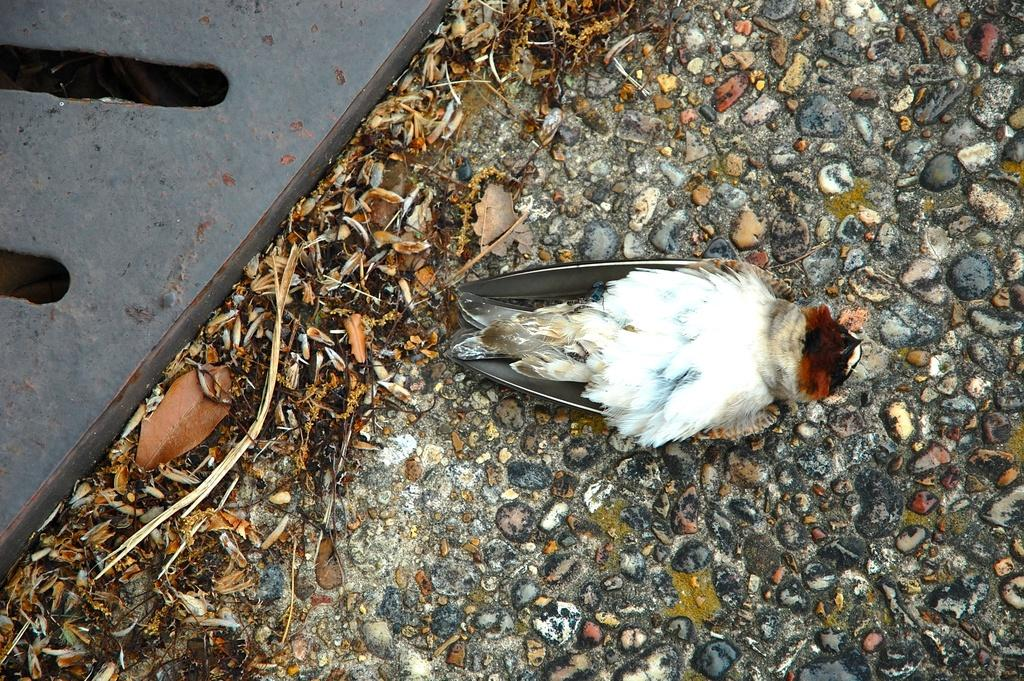What is on the ground in the image? There is a dead bird on the ground in the image. What type of vegetation is present at the bottom of the image? Dried grass is present at the bottom of the image. What type of material is visible on the surface in the image? There are stones on the surface in the image. What type of beef is being served in the image? There is no beef present in the image; it features a dead bird on the ground. What type of art can be seen in the image? There is no art present in the image; it features a dead bird, dried grass, and stones. 